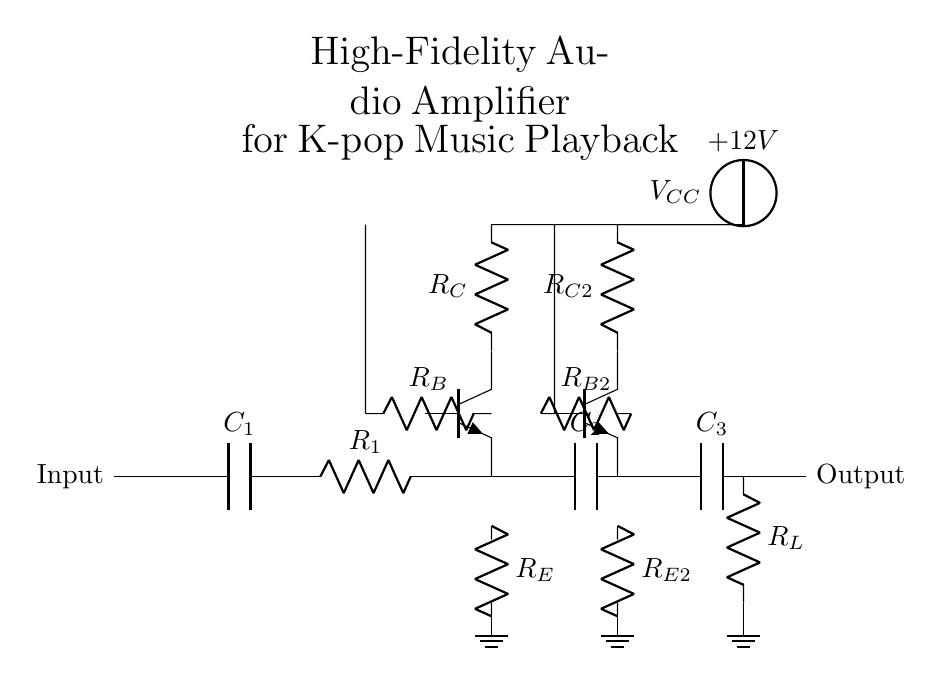What is the type of amplifier in this circuit? The circuit diagram features transistor-based components, specifically bipolar junction transistors, which are commonly used in analog amplifier circuits. Thus, it is classified as a bipolar junction transistor amplifier.
Answer: bipolar junction transistor amplifier How many stages of amplification are present? The diagram shows two distinct stages of amplification, each utilizing a transistor for signal boost, as indicated by the presence of two transistors labeled Q1 and Q2.
Answer: two What is the value of the power supply voltage? The circuit diagram indicates a voltage source labeled V_CC connected to the circuit, which is clearly marked as eleven volts, specified in the diagram.
Answer: twelve volts What components are used for coupling in this amplifier? The amplifier utilizes capacitors for coupling between stages, specifically C2 between the first and second amplification stages, and C3 at the output stage.
Answer: coupling capacitors What are the resistors labeled in the first amplification stage? In the first amplification stage, two resistors are depicted: R_E connected to the emitter, which is labeled as the emitter resistor, and R_C connected to the collector, marked as the collector resistor.
Answer: R_E and R_C Which component is primarily responsible for frequency response in audio applications? The coupling capacitors C1, C2, and C3 are primarily responsible for setting the frequency response characteristics by allowing AC signals to pass while blocking DC, which is crucial for audio signal processing.
Answer: coupling capacitors What is the purpose of the ground connection in the circuit? The ground connection serves as a reference point for the circuit, stabilizing voltages throughout and providing a return path for current, essential for proper amplifier operation and biasing of transistors.
Answer: reference point 